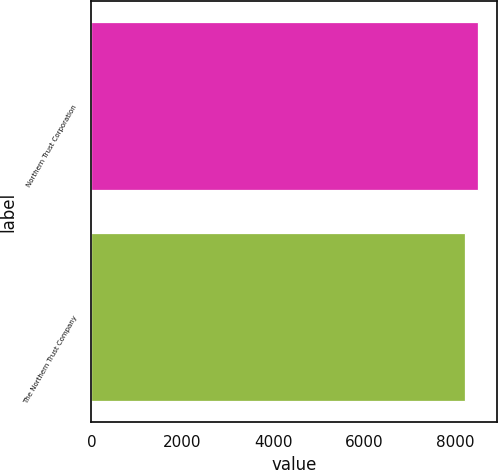Convert chart to OTSL. <chart><loc_0><loc_0><loc_500><loc_500><bar_chart><fcel>Northern Trust Corporation<fcel>The Northern Trust Company<nl><fcel>8480.4<fcel>8201.4<nl></chart> 